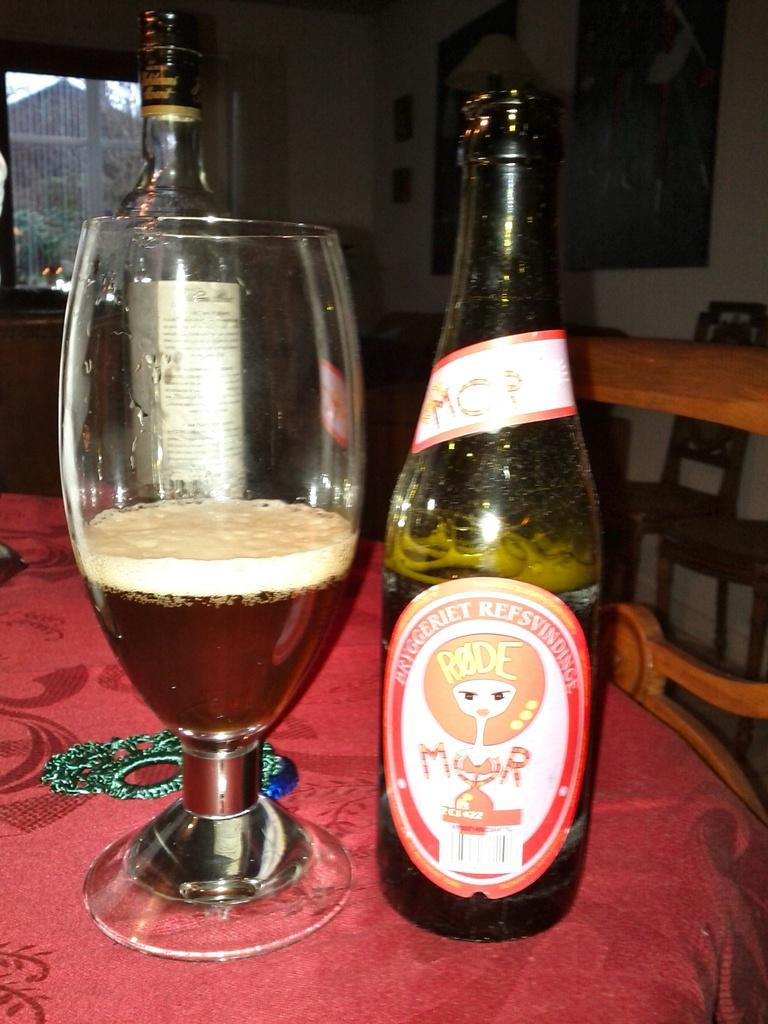<image>
Present a compact description of the photo's key features. A bottle of beer with foreign markings spelling out Bryggeriet sits next to a glass cup half filled with it. 